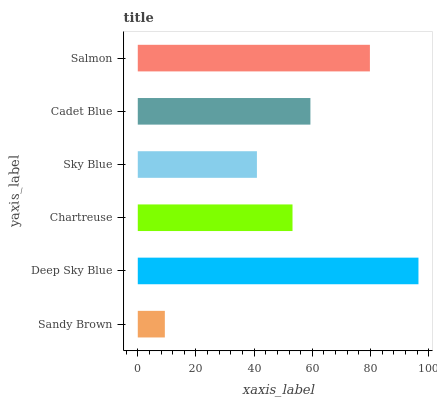Is Sandy Brown the minimum?
Answer yes or no. Yes. Is Deep Sky Blue the maximum?
Answer yes or no. Yes. Is Chartreuse the minimum?
Answer yes or no. No. Is Chartreuse the maximum?
Answer yes or no. No. Is Deep Sky Blue greater than Chartreuse?
Answer yes or no. Yes. Is Chartreuse less than Deep Sky Blue?
Answer yes or no. Yes. Is Chartreuse greater than Deep Sky Blue?
Answer yes or no. No. Is Deep Sky Blue less than Chartreuse?
Answer yes or no. No. Is Cadet Blue the high median?
Answer yes or no. Yes. Is Chartreuse the low median?
Answer yes or no. Yes. Is Salmon the high median?
Answer yes or no. No. Is Deep Sky Blue the low median?
Answer yes or no. No. 